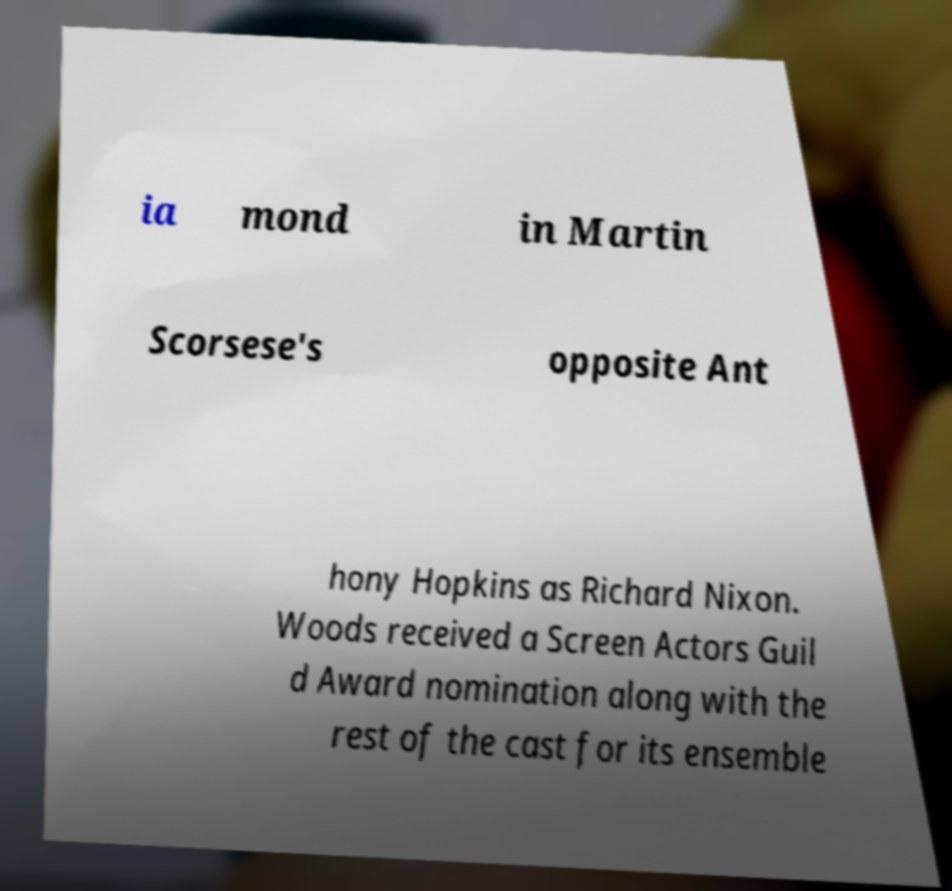Can you accurately transcribe the text from the provided image for me? ia mond in Martin Scorsese's opposite Ant hony Hopkins as Richard Nixon. Woods received a Screen Actors Guil d Award nomination along with the rest of the cast for its ensemble 